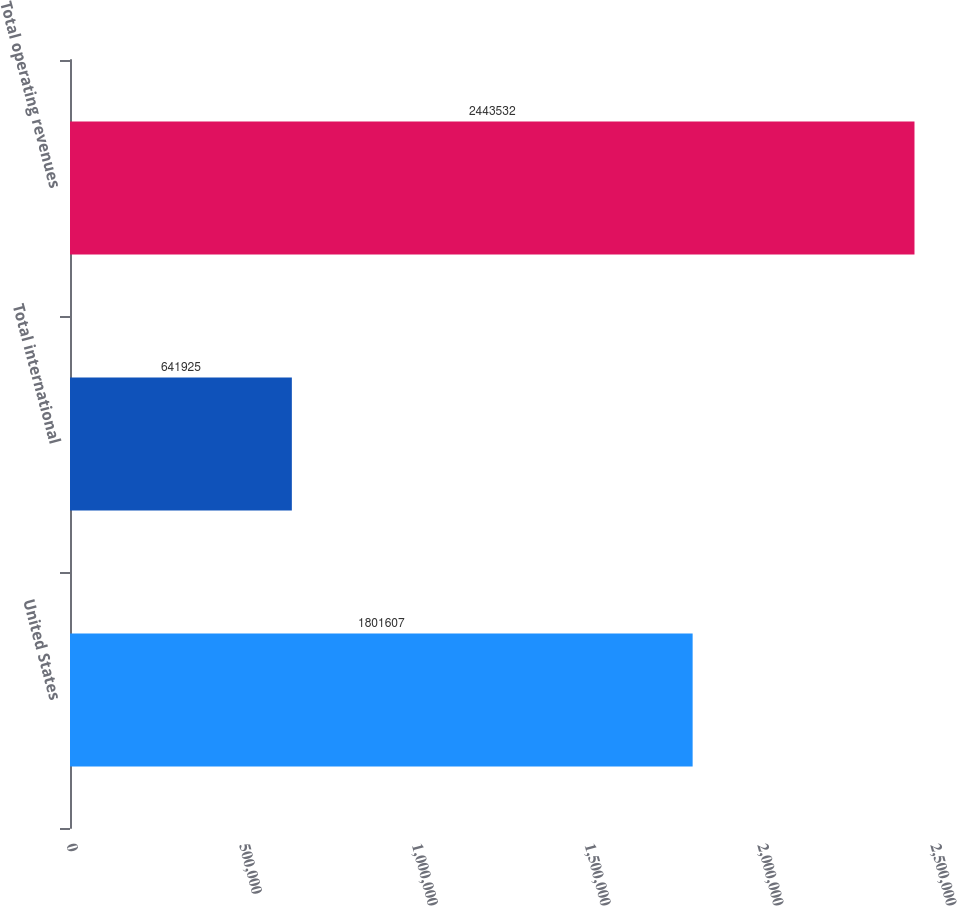Convert chart to OTSL. <chart><loc_0><loc_0><loc_500><loc_500><bar_chart><fcel>United States<fcel>Total international<fcel>Total operating revenues<nl><fcel>1.80161e+06<fcel>641925<fcel>2.44353e+06<nl></chart> 